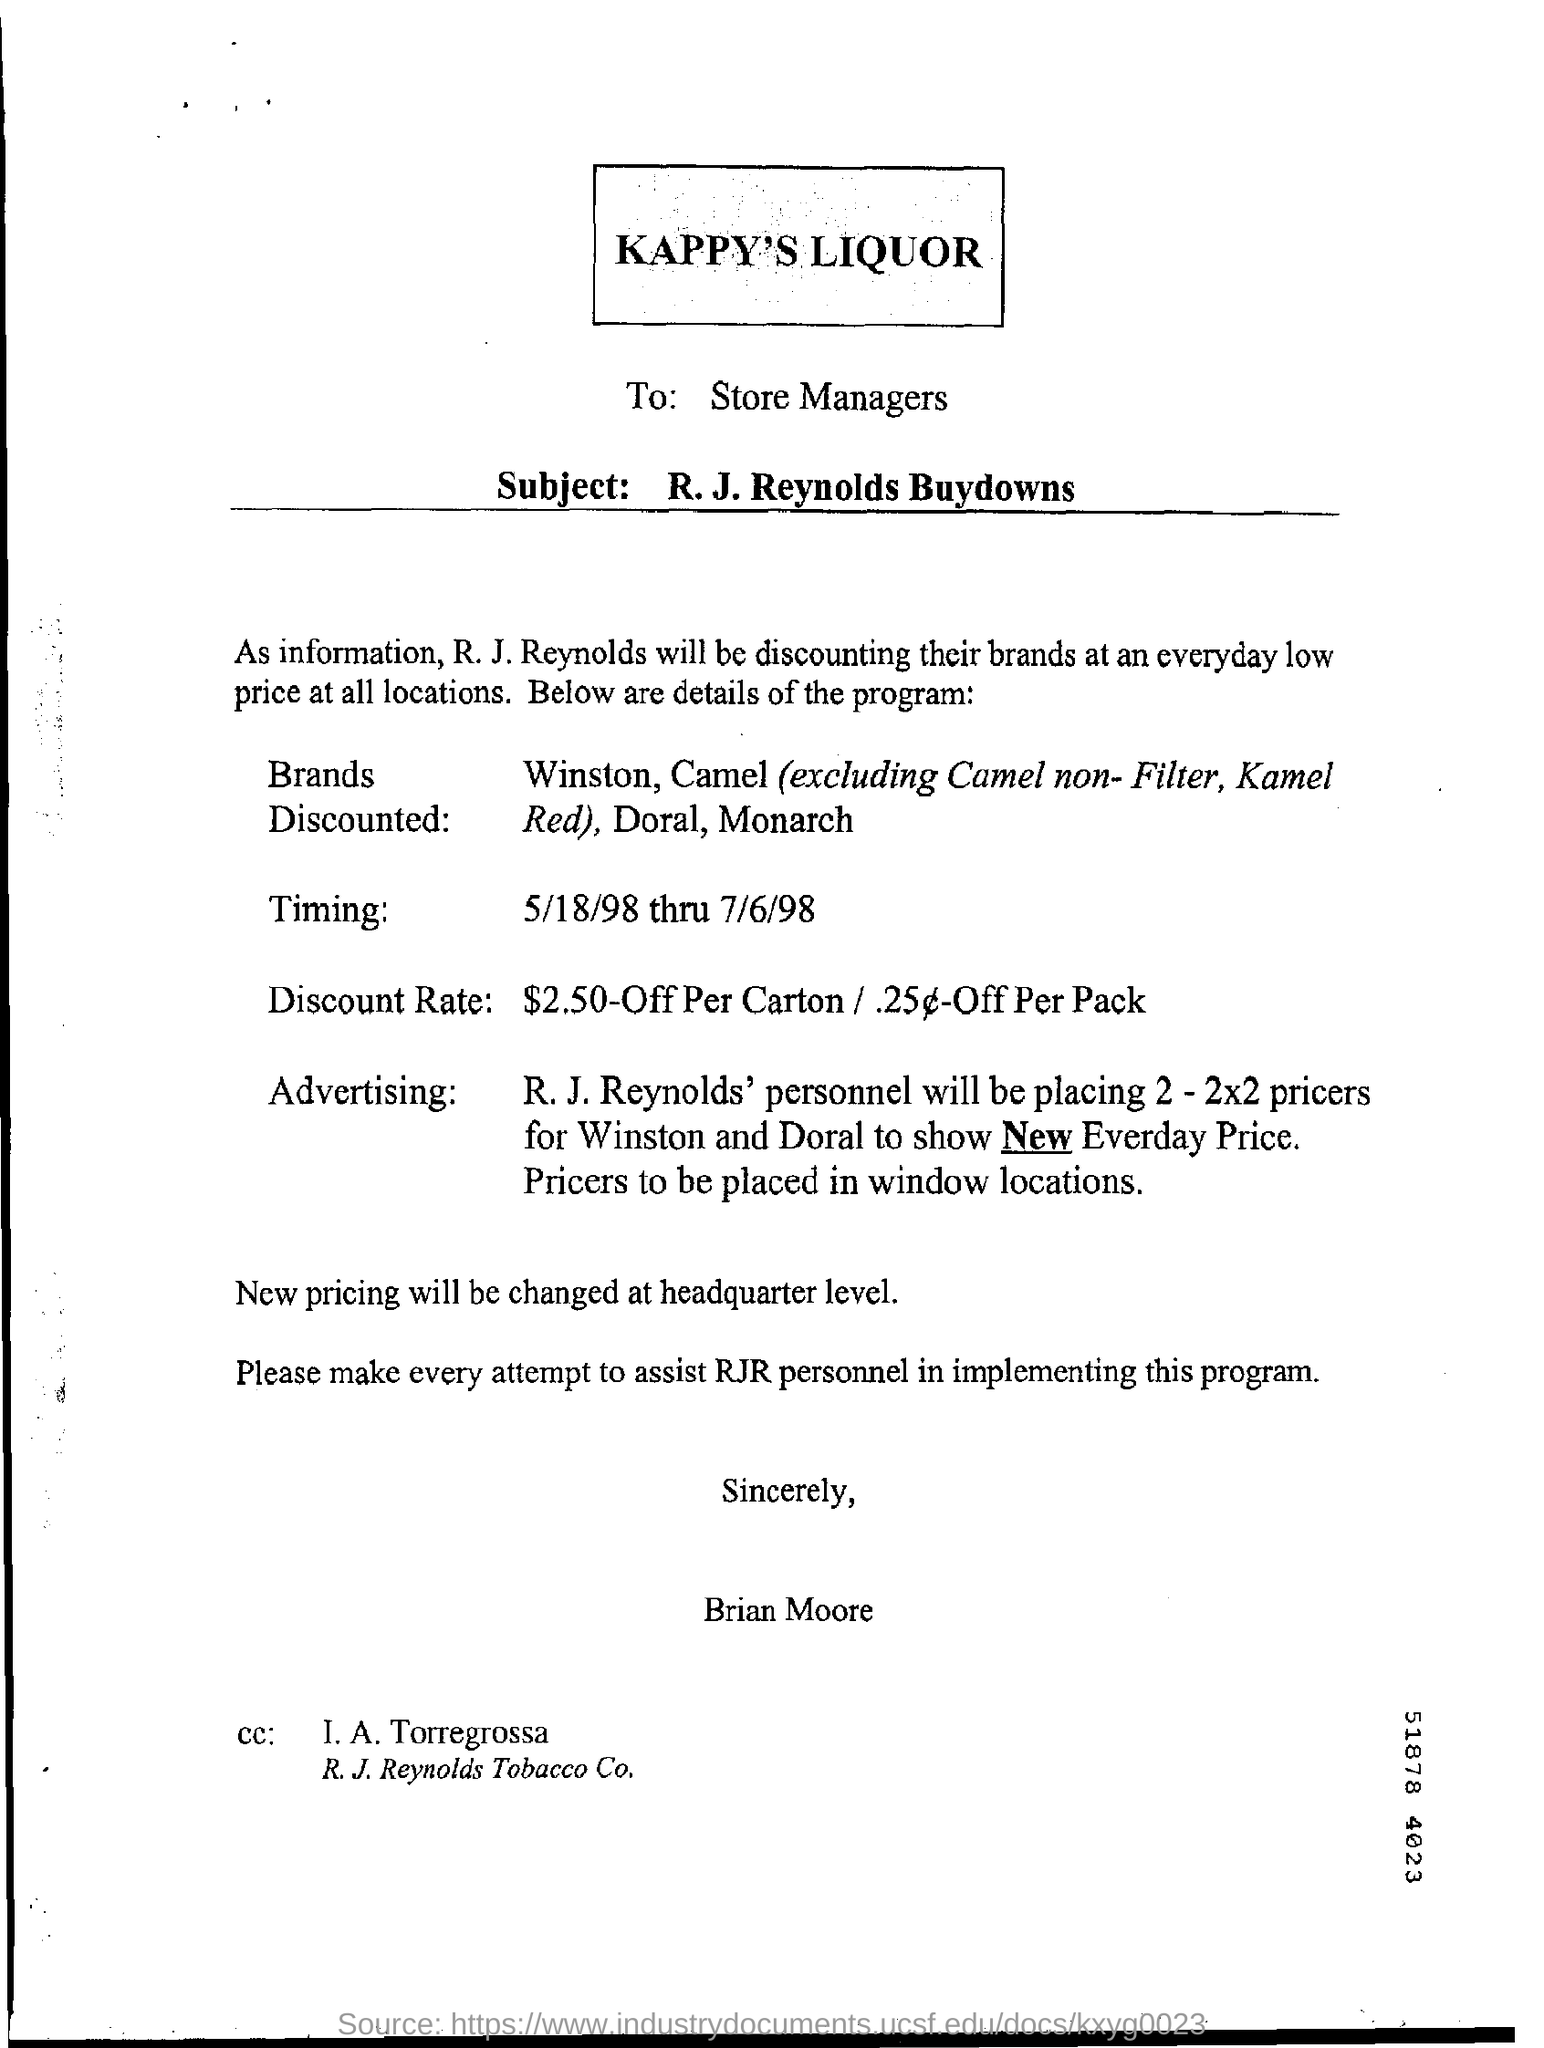To whom the letter was written ?
Give a very brief answer. STORE MANAGERS. What is the timing mentioned ?
Keep it short and to the point. 5/18/98 thru 7/6/98. 